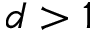<formula> <loc_0><loc_0><loc_500><loc_500>d > 1</formula> 